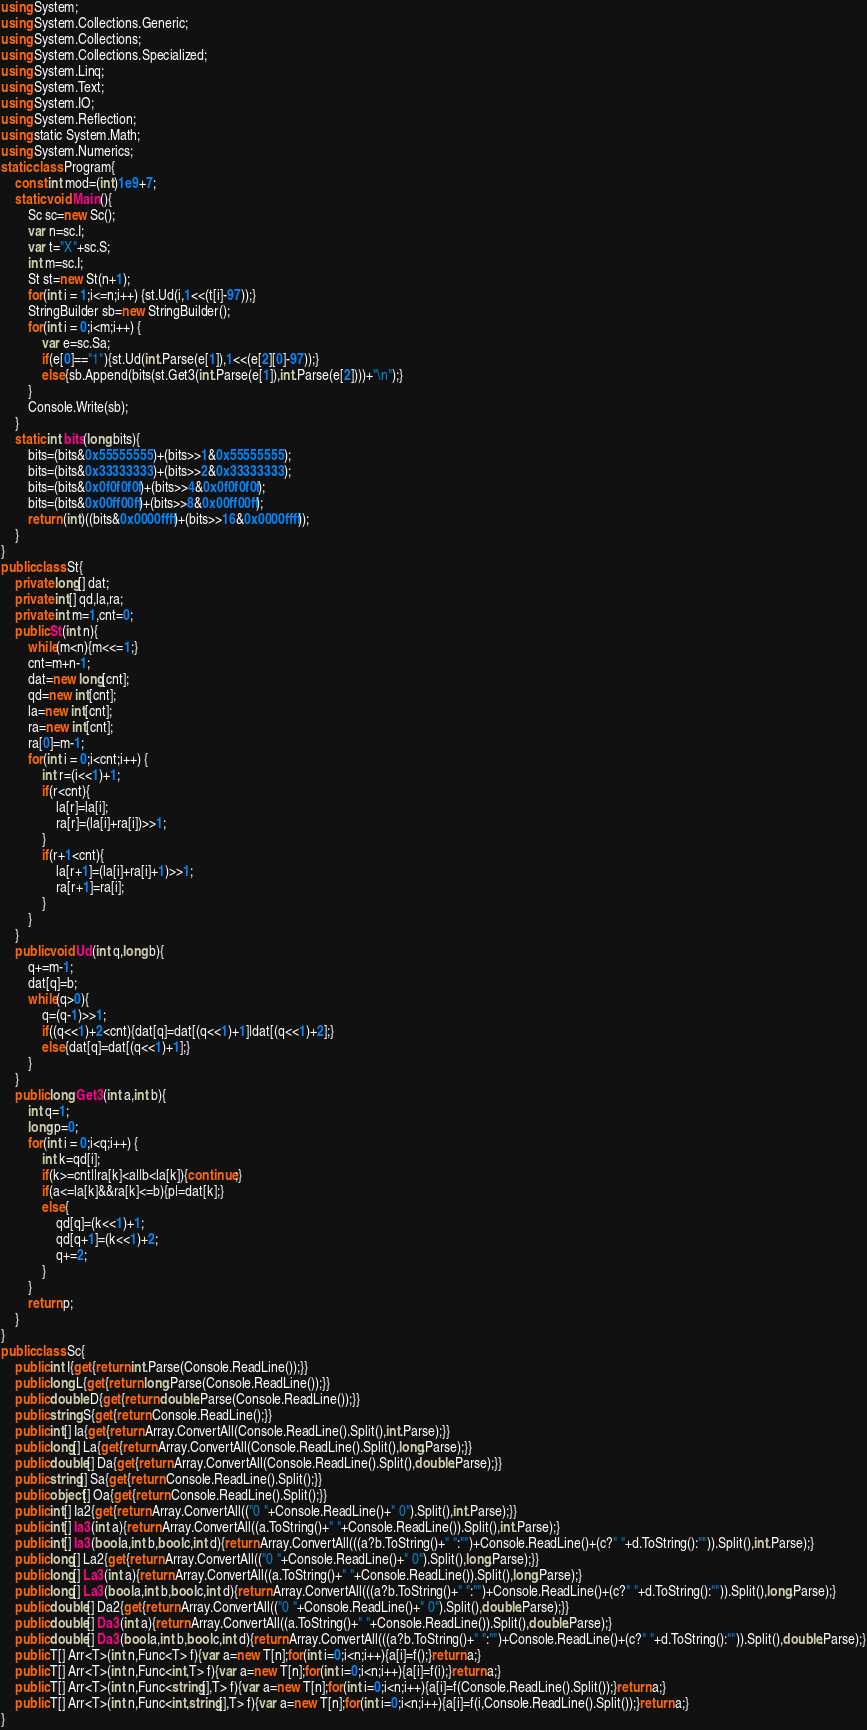Convert code to text. <code><loc_0><loc_0><loc_500><loc_500><_C#_>using System;
using System.Collections.Generic;
using System.Collections;
using System.Collections.Specialized;
using System.Linq;
using System.Text;
using System.IO;
using System.Reflection;
using static System.Math;
using System.Numerics;
static class Program{
	const int mod=(int)1e9+7;
	static void Main(){
		Sc sc=new Sc();
		var n=sc.I;
		var t="X"+sc.S;
		int m=sc.I;
		St st=new St(n+1);
		for(int i = 1;i<=n;i++) {st.Ud(i,1<<(t[i]-97));}
		StringBuilder sb=new StringBuilder();
		for(int i = 0;i<m;i++) {
			var e=sc.Sa;
			if(e[0]=="1"){st.Ud(int.Parse(e[1]),1<<(e[2][0]-97));}
			else{sb.Append(bits(st.Get3(int.Parse(e[1]),int.Parse(e[2])))+"\n");}
		}
		Console.Write(sb);
	}
	static int bits(long bits){
		bits=(bits&0x55555555)+(bits>>1&0x55555555);
		bits=(bits&0x33333333)+(bits>>2&0x33333333);
		bits=(bits&0x0f0f0f0f)+(bits>>4&0x0f0f0f0f);
		bits=(bits&0x00ff00ff)+(bits>>8&0x00ff00ff);
		return (int)((bits&0x0000ffff)+(bits>>16&0x0000ffff));
	}
}
public class St{
	private long[] dat;
	private int[] qd,la,ra;
	private int m=1,cnt=0;
	public St(int n){
		while(m<n){m<<=1;}
		cnt=m+n-1;
		dat=new long[cnt];
		qd=new int[cnt];
		la=new int[cnt];
		ra=new int[cnt];
		ra[0]=m-1;
		for(int i = 0;i<cnt;i++) {
			int r=(i<<1)+1;
			if(r<cnt){
				la[r]=la[i];
				ra[r]=(la[i]+ra[i])>>1;
			}
			if(r+1<cnt){
				la[r+1]=(la[i]+ra[i]+1)>>1;
				ra[r+1]=ra[i];
			}
		}
	}
	public void Ud(int q,long b){
		q+=m-1;
		dat[q]=b;
		while(q>0){
			q=(q-1)>>1;
			if((q<<1)+2<cnt){dat[q]=dat[(q<<1)+1]|dat[(q<<1)+2];}
			else{dat[q]=dat[(q<<1)+1];}
		}
	}
	public long Get3(int a,int b){
		int q=1;
		long p=0;
		for(int i = 0;i<q;i++) {
			int k=qd[i];
			if(k>=cnt||ra[k]<a||b<la[k]){continue;}
			if(a<=la[k]&&ra[k]<=b){p|=dat[k];}
			else{
				qd[q]=(k<<1)+1;
				qd[q+1]=(k<<1)+2;
				q+=2;
			}
		}
		return p;
	}
}
public class Sc{
	public int I{get{return int.Parse(Console.ReadLine());}}
	public long L{get{return long.Parse(Console.ReadLine());}}
	public double D{get{return double.Parse(Console.ReadLine());}}
	public string S{get{return Console.ReadLine();}}
	public int[] Ia{get{return Array.ConvertAll(Console.ReadLine().Split(),int.Parse);}}
	public long[] La{get{return Array.ConvertAll(Console.ReadLine().Split(),long.Parse);}}
	public double[] Da{get{return Array.ConvertAll(Console.ReadLine().Split(),double.Parse);}}
	public string[] Sa{get{return Console.ReadLine().Split();}}
	public object[] Oa{get{return Console.ReadLine().Split();}}
	public int[] Ia2{get{return Array.ConvertAll(("0 "+Console.ReadLine()+" 0").Split(),int.Parse);}}
	public int[] Ia3(int a){return Array.ConvertAll((a.ToString()+" "+Console.ReadLine()).Split(),int.Parse);}
	public int[] Ia3(bool a,int b,bool c,int d){return Array.ConvertAll(((a?b.ToString()+" ":"")+Console.ReadLine()+(c?" "+d.ToString():"")).Split(),int.Parse);}
	public long[] La2{get{return Array.ConvertAll(("0 "+Console.ReadLine()+" 0").Split(),long.Parse);}}
	public long[] La3(int a){return Array.ConvertAll((a.ToString()+" "+Console.ReadLine()).Split(),long.Parse);}
	public long[] La3(bool a,int b,bool c,int d){return Array.ConvertAll(((a?b.ToString()+" ":"")+Console.ReadLine()+(c?" "+d.ToString():"")).Split(),long.Parse);}
	public double[] Da2{get{return Array.ConvertAll(("0 "+Console.ReadLine()+" 0").Split(),double.Parse);}}
	public double[] Da3(int a){return Array.ConvertAll((a.ToString()+" "+Console.ReadLine()).Split(),double.Parse);}
	public double[] Da3(bool a,int b,bool c,int d){return Array.ConvertAll(((a?b.ToString()+" ":"")+Console.ReadLine()+(c?" "+d.ToString():"")).Split(),double.Parse);}
	public T[] Arr<T>(int n,Func<T> f){var a=new T[n];for(int i=0;i<n;i++){a[i]=f();}return a;}
	public T[] Arr<T>(int n,Func<int,T> f){var a=new T[n];for(int i=0;i<n;i++){a[i]=f(i);}return a;}
	public T[] Arr<T>(int n,Func<string[],T> f){var a=new T[n];for(int i=0;i<n;i++){a[i]=f(Console.ReadLine().Split());}return a;}
	public T[] Arr<T>(int n,Func<int,string[],T> f){var a=new T[n];for(int i=0;i<n;i++){a[i]=f(i,Console.ReadLine().Split());}return a;}
}</code> 